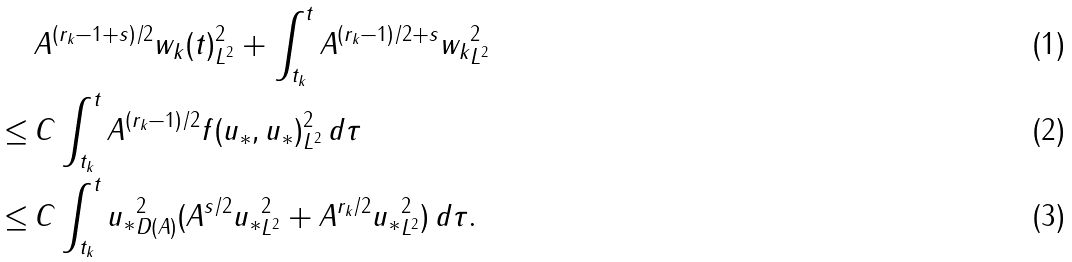<formula> <loc_0><loc_0><loc_500><loc_500>& \, \| A ^ { ( r _ { k } - 1 + s ) / 2 } w _ { k } ( t ) \| _ { L ^ { 2 } } ^ { 2 } + \int _ { t _ { k } } ^ { t } \| A ^ { ( r _ { k } - 1 ) / 2 + s } w _ { k } \| _ { L ^ { 2 } } ^ { 2 } \\ \leq & \, C \int _ { t _ { k } } ^ { t } \| A ^ { ( r _ { k } - 1 ) / 2 } f ( u _ { * } , u _ { * } ) \| _ { L ^ { 2 } } ^ { 2 } \, d \tau \\ \leq & \, C \int _ { t _ { k } } ^ { t } \| u _ { * } \| _ { D ( A ) } ^ { 2 } ( \| A ^ { s / 2 } u _ { * } \| _ { L ^ { 2 } } ^ { 2 } + \| A ^ { r _ { k } / 2 } u _ { * } \| _ { L ^ { 2 } } ^ { 2 } ) \, d \tau .</formula> 